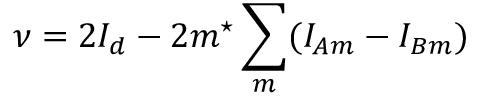<formula> <loc_0><loc_0><loc_500><loc_500>\nu = 2 I _ { d } - 2 m ^ { ^ { * } } \sum _ { m } ( I _ { A m } - I _ { B m } )</formula> 